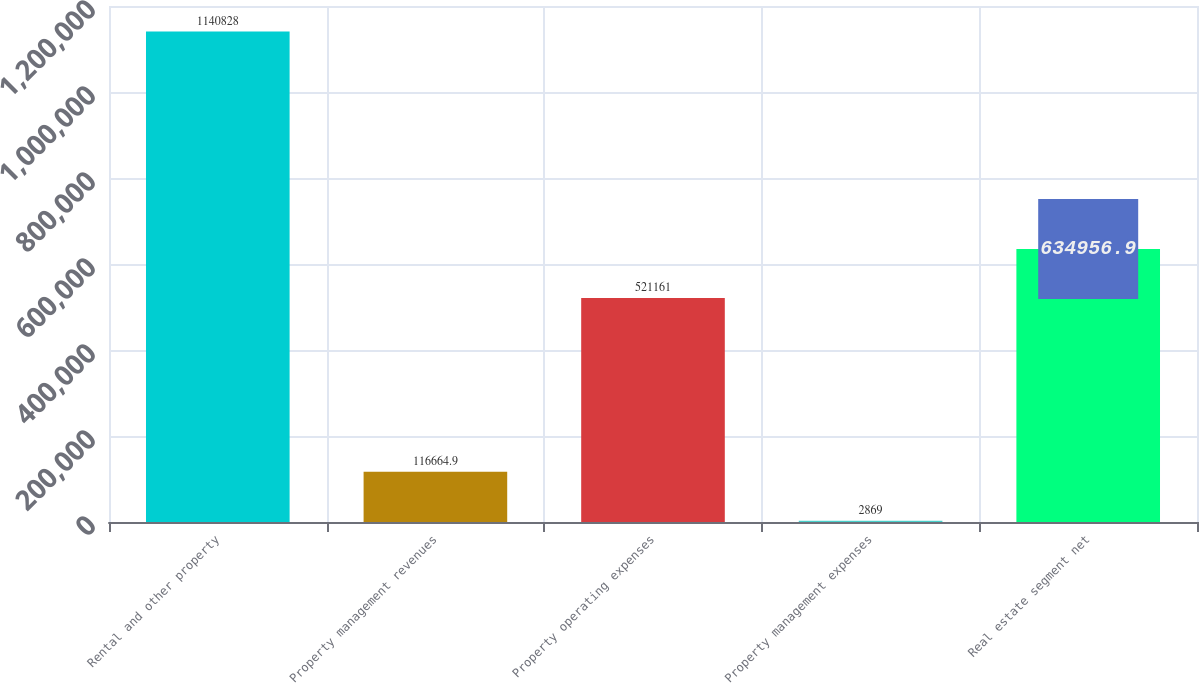Convert chart to OTSL. <chart><loc_0><loc_0><loc_500><loc_500><bar_chart><fcel>Rental and other property<fcel>Property management revenues<fcel>Property operating expenses<fcel>Property management expenses<fcel>Real estate segment net<nl><fcel>1.14083e+06<fcel>116665<fcel>521161<fcel>2869<fcel>634957<nl></chart> 